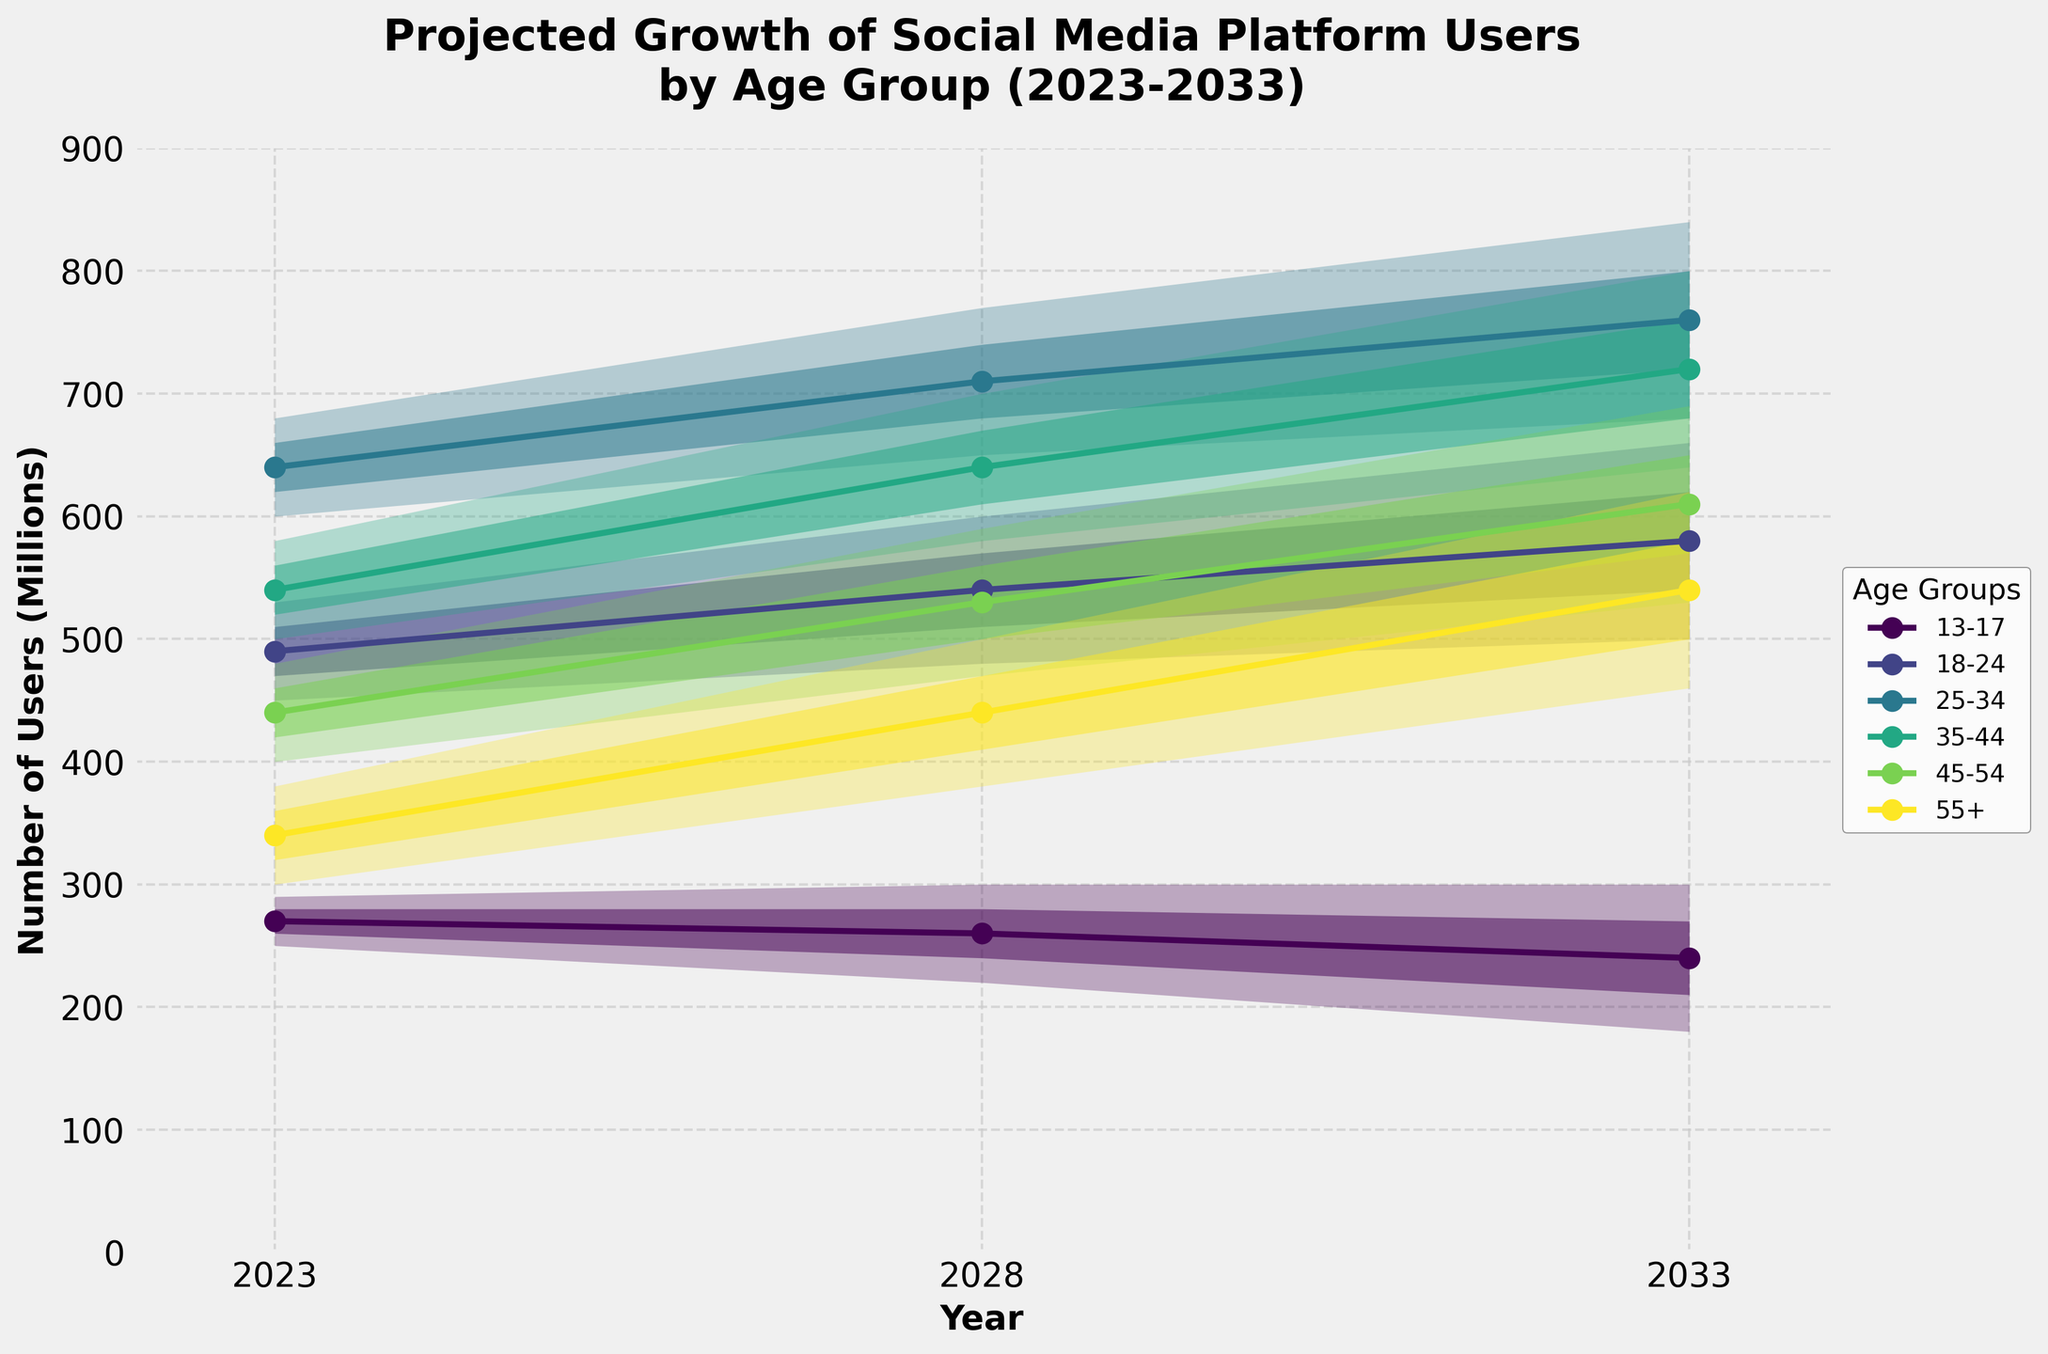What is the projected number of users in the 18-24 age group for 2023? Refer to the plot and look at the marker for the 18-24 age group in 2023, which is marked with a line and dots. The value for the projected number of users is approximately 490 million.
Answer: 490 million Which age group is projected to have the highest number of users in 2033? Look at the markers indicating the middle estimate for each age group in 2033. The 25-34 age group has the highest middle estimate value, indicated on the y-axis.
Answer: 25-34 How does the projected number of users aged 13-17 change from 2023 to 2033? Compare the markers indicating the middle estimate for the 13-17 age group in 2023 and 2033. The number decreases from around 270 million to around 240 million.
Answer: Decreases from 270 million to 240 million What trend do you observe for the 55+ age group between 2023 and 2033? Observe the marker line and its movement for the 55+ age group between the years 2023 and 2033. The number of users in this age group is increasing over time.
Answer: Increasing Which age group shows the most significant increase in users from 2023 to 2033? Compare the markers for all age groups between 2023 and 2033, focusing on the change. The 25-34 age group shows the largest increase, rising from 640 million to 760 million.
Answer: 25-34 In 2028, which age group has the narrowest uncertainty range? For each age group, compare the distance between the low and high estimates in 2028. The 13-17 age group displays the narrowest range from approximately 220 to 300 million.
Answer: 13-17 What is the total projected number of users for all age groups combined in 2023 using the middle estimates? Sum the middle estimates for all the age groups in 2023: 270 + 490 + 640 + 540 + 440 + 340 = 2720 million.
Answer: 2720 million 